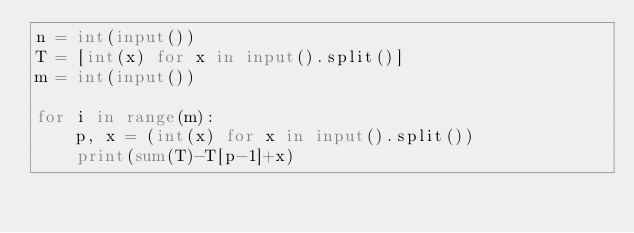<code> <loc_0><loc_0><loc_500><loc_500><_Python_>n = int(input())
T = [int(x) for x in input().split()]
m = int(input())

for i in range(m):
    p, x = (int(x) for x in input().split())
    print(sum(T)-T[p-1]+x)
</code> 